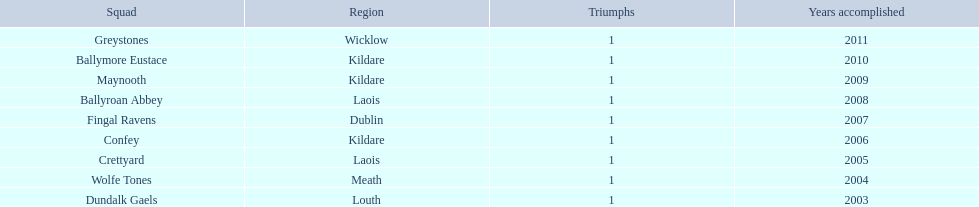Before confey, which team can be found? Fingal Ravens. 